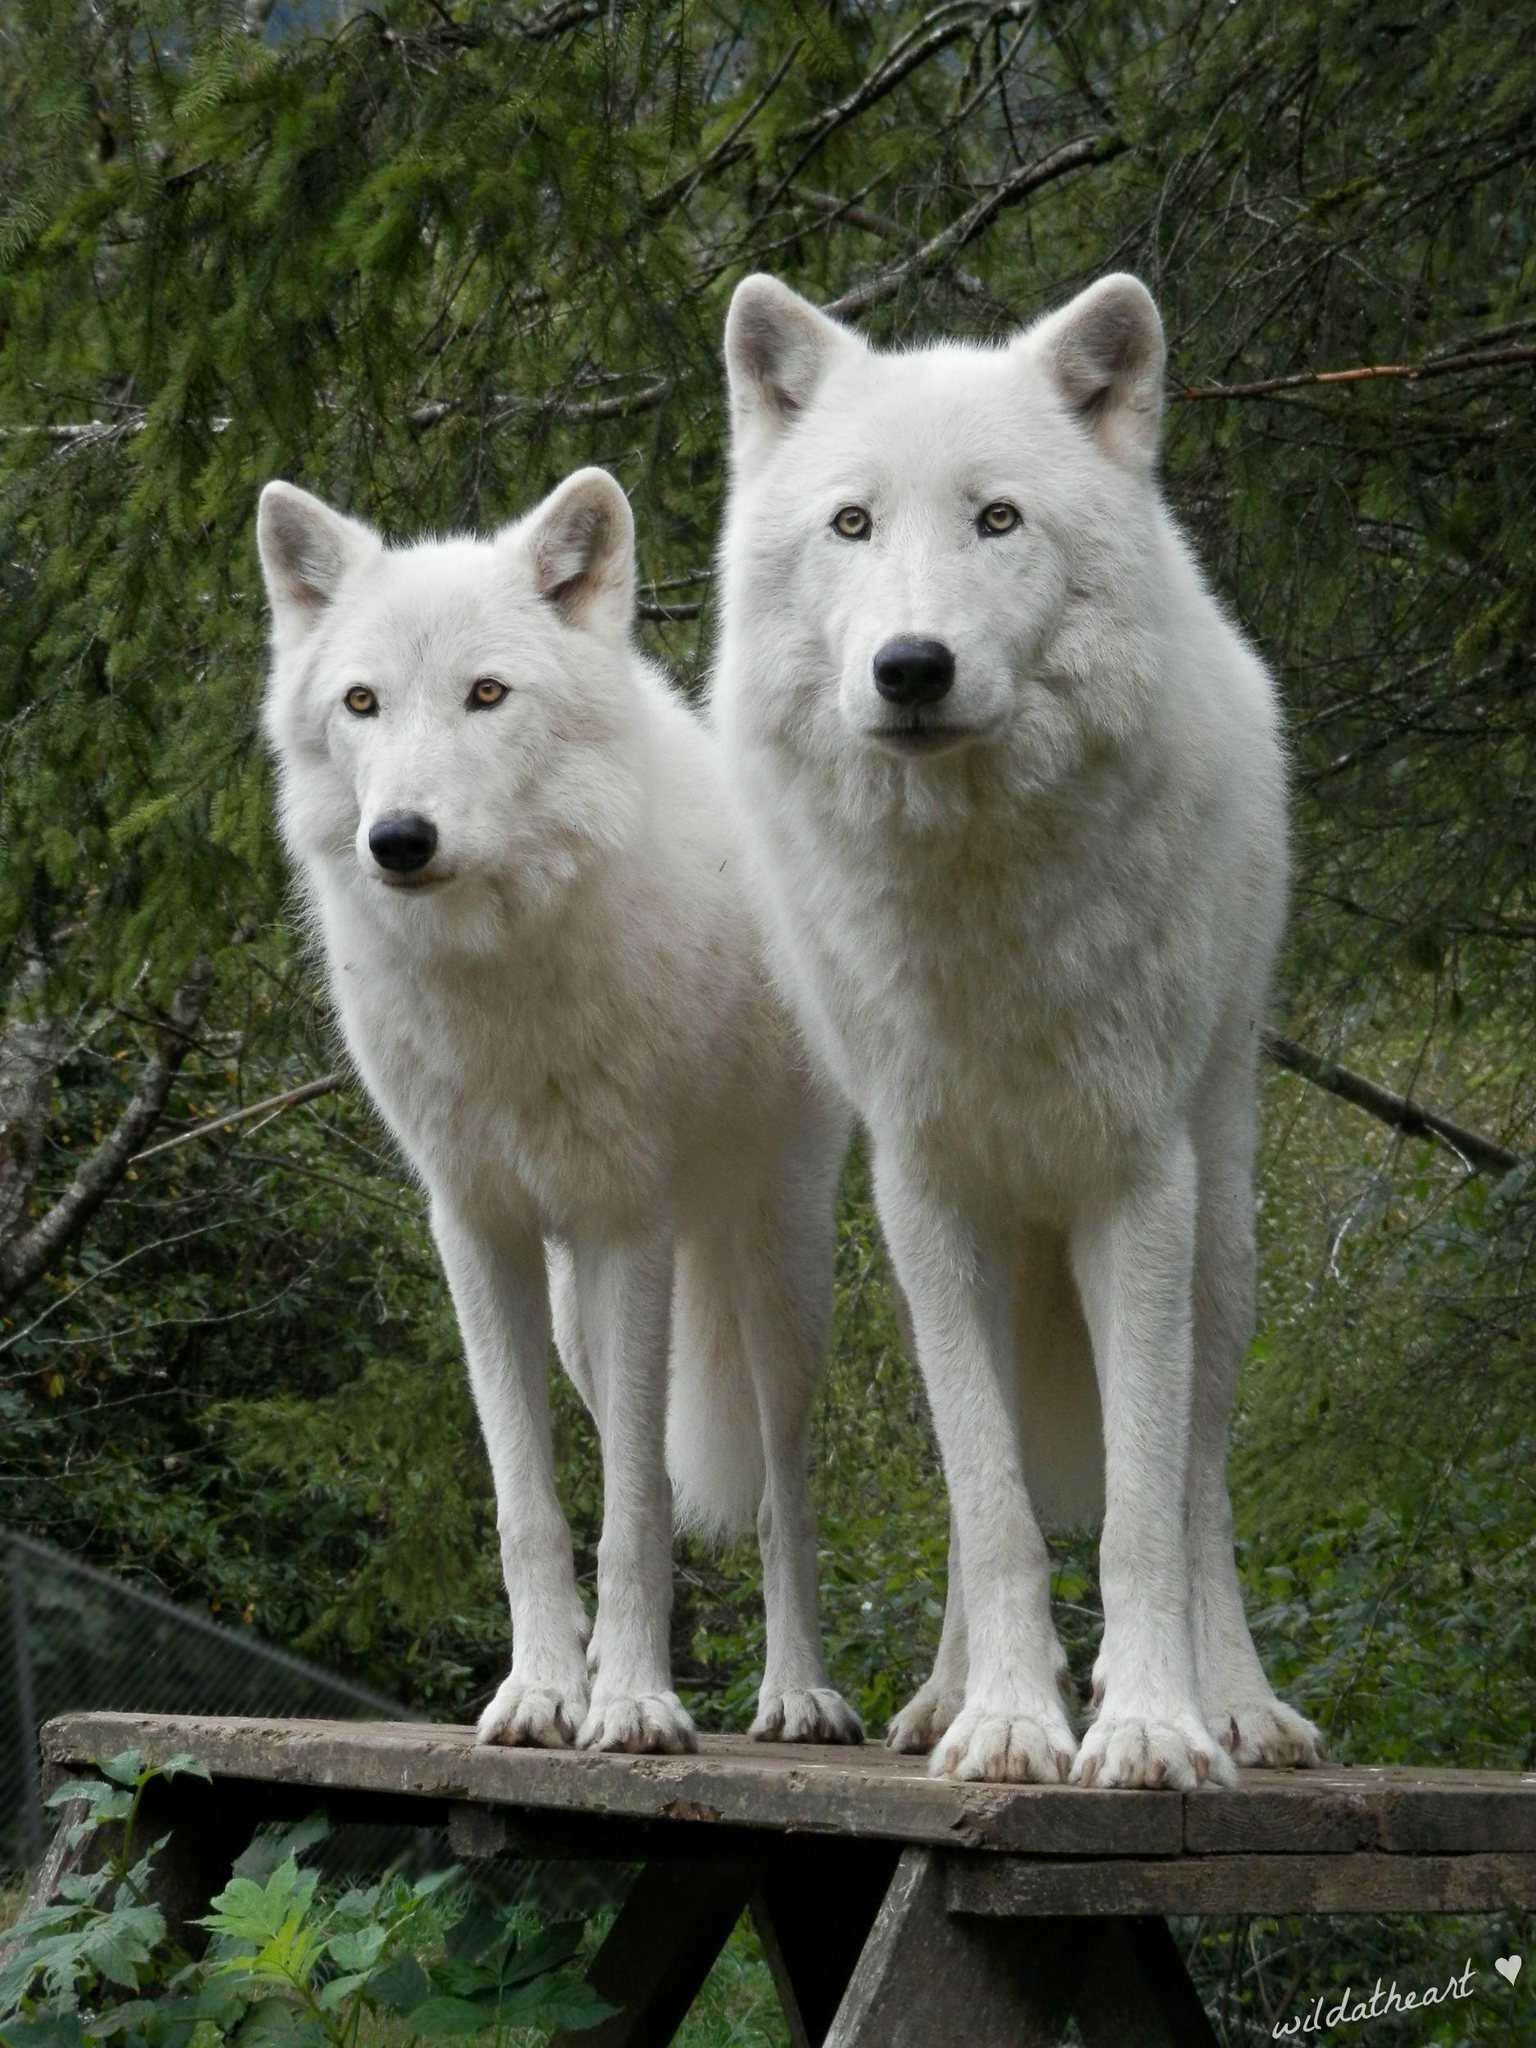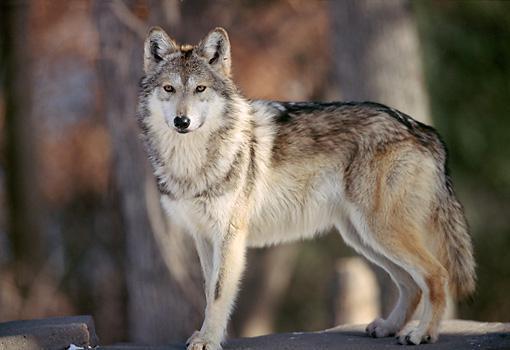The first image is the image on the left, the second image is the image on the right. Evaluate the accuracy of this statement regarding the images: "The left image contains twice as many wolves as the right image.". Is it true? Answer yes or no. Yes. The first image is the image on the left, the second image is the image on the right. Evaluate the accuracy of this statement regarding the images: "Three wolves are visible.". Is it true? Answer yes or no. Yes. 